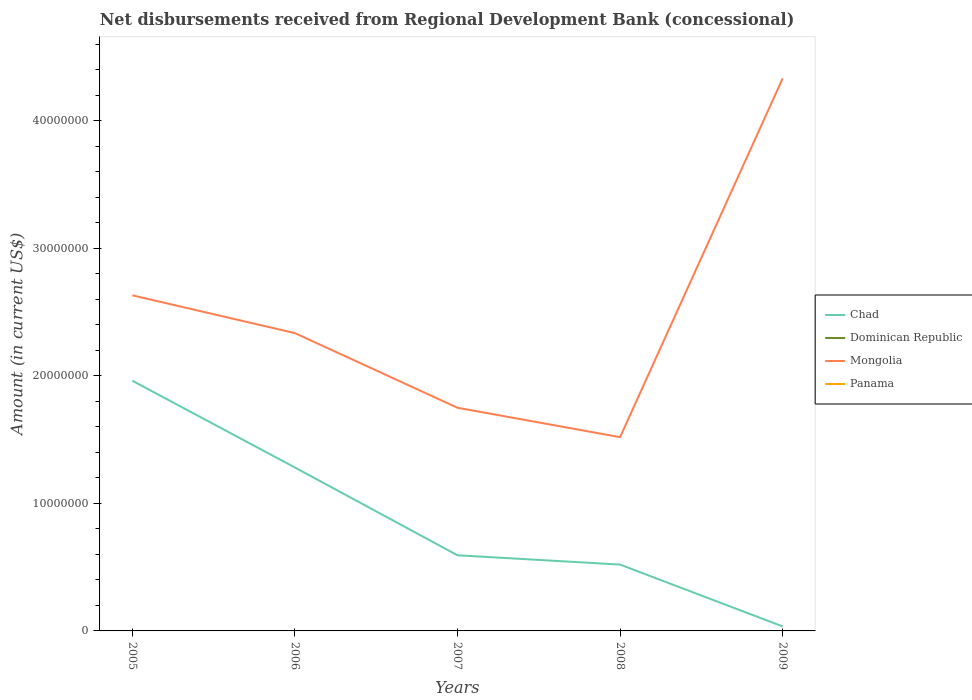How many different coloured lines are there?
Make the answer very short. 2. Across all years, what is the maximum amount of disbursements received from Regional Development Bank in Chad?
Provide a succinct answer. 3.53e+05. What is the total amount of disbursements received from Regional Development Bank in Chad in the graph?
Your response must be concise. 6.80e+06. What is the difference between the highest and the second highest amount of disbursements received from Regional Development Bank in Chad?
Offer a terse response. 1.93e+07. What is the difference between the highest and the lowest amount of disbursements received from Regional Development Bank in Dominican Republic?
Keep it short and to the point. 0. Is the amount of disbursements received from Regional Development Bank in Panama strictly greater than the amount of disbursements received from Regional Development Bank in Chad over the years?
Offer a terse response. Yes. How many lines are there?
Ensure brevity in your answer.  2. How many years are there in the graph?
Your answer should be compact. 5. Does the graph contain grids?
Your response must be concise. No. What is the title of the graph?
Keep it short and to the point. Net disbursements received from Regional Development Bank (concessional). What is the label or title of the X-axis?
Give a very brief answer. Years. What is the Amount (in current US$) in Chad in 2005?
Keep it short and to the point. 1.96e+07. What is the Amount (in current US$) of Dominican Republic in 2005?
Keep it short and to the point. 0. What is the Amount (in current US$) of Mongolia in 2005?
Make the answer very short. 2.63e+07. What is the Amount (in current US$) in Panama in 2005?
Keep it short and to the point. 0. What is the Amount (in current US$) in Chad in 2006?
Your response must be concise. 1.28e+07. What is the Amount (in current US$) in Mongolia in 2006?
Give a very brief answer. 2.33e+07. What is the Amount (in current US$) in Panama in 2006?
Keep it short and to the point. 0. What is the Amount (in current US$) in Chad in 2007?
Keep it short and to the point. 5.93e+06. What is the Amount (in current US$) of Dominican Republic in 2007?
Offer a very short reply. 0. What is the Amount (in current US$) in Mongolia in 2007?
Ensure brevity in your answer.  1.75e+07. What is the Amount (in current US$) of Panama in 2007?
Your answer should be very brief. 0. What is the Amount (in current US$) in Chad in 2008?
Your response must be concise. 5.20e+06. What is the Amount (in current US$) in Mongolia in 2008?
Offer a very short reply. 1.52e+07. What is the Amount (in current US$) of Chad in 2009?
Offer a terse response. 3.53e+05. What is the Amount (in current US$) in Mongolia in 2009?
Provide a short and direct response. 4.33e+07. Across all years, what is the maximum Amount (in current US$) in Chad?
Offer a terse response. 1.96e+07. Across all years, what is the maximum Amount (in current US$) in Mongolia?
Offer a very short reply. 4.33e+07. Across all years, what is the minimum Amount (in current US$) of Chad?
Make the answer very short. 3.53e+05. Across all years, what is the minimum Amount (in current US$) of Mongolia?
Provide a short and direct response. 1.52e+07. What is the total Amount (in current US$) of Chad in the graph?
Make the answer very short. 4.39e+07. What is the total Amount (in current US$) in Dominican Republic in the graph?
Your answer should be very brief. 0. What is the total Amount (in current US$) in Mongolia in the graph?
Give a very brief answer. 1.26e+08. What is the difference between the Amount (in current US$) in Chad in 2005 and that in 2006?
Provide a succinct answer. 6.80e+06. What is the difference between the Amount (in current US$) in Mongolia in 2005 and that in 2006?
Offer a very short reply. 2.96e+06. What is the difference between the Amount (in current US$) in Chad in 2005 and that in 2007?
Make the answer very short. 1.37e+07. What is the difference between the Amount (in current US$) in Mongolia in 2005 and that in 2007?
Ensure brevity in your answer.  8.81e+06. What is the difference between the Amount (in current US$) in Chad in 2005 and that in 2008?
Offer a terse response. 1.44e+07. What is the difference between the Amount (in current US$) of Mongolia in 2005 and that in 2008?
Keep it short and to the point. 1.11e+07. What is the difference between the Amount (in current US$) in Chad in 2005 and that in 2009?
Offer a very short reply. 1.93e+07. What is the difference between the Amount (in current US$) in Mongolia in 2005 and that in 2009?
Your answer should be compact. -1.70e+07. What is the difference between the Amount (in current US$) in Chad in 2006 and that in 2007?
Your answer should be very brief. 6.88e+06. What is the difference between the Amount (in current US$) of Mongolia in 2006 and that in 2007?
Your response must be concise. 5.85e+06. What is the difference between the Amount (in current US$) in Chad in 2006 and that in 2008?
Offer a very short reply. 7.61e+06. What is the difference between the Amount (in current US$) in Mongolia in 2006 and that in 2008?
Your response must be concise. 8.16e+06. What is the difference between the Amount (in current US$) of Chad in 2006 and that in 2009?
Keep it short and to the point. 1.25e+07. What is the difference between the Amount (in current US$) in Mongolia in 2006 and that in 2009?
Keep it short and to the point. -2.00e+07. What is the difference between the Amount (in current US$) in Chad in 2007 and that in 2008?
Your answer should be compact. 7.30e+05. What is the difference between the Amount (in current US$) in Mongolia in 2007 and that in 2008?
Make the answer very short. 2.30e+06. What is the difference between the Amount (in current US$) in Chad in 2007 and that in 2009?
Offer a very short reply. 5.58e+06. What is the difference between the Amount (in current US$) in Mongolia in 2007 and that in 2009?
Provide a succinct answer. -2.58e+07. What is the difference between the Amount (in current US$) in Chad in 2008 and that in 2009?
Your answer should be compact. 4.85e+06. What is the difference between the Amount (in current US$) in Mongolia in 2008 and that in 2009?
Ensure brevity in your answer.  -2.81e+07. What is the difference between the Amount (in current US$) in Chad in 2005 and the Amount (in current US$) in Mongolia in 2006?
Make the answer very short. -3.73e+06. What is the difference between the Amount (in current US$) in Chad in 2005 and the Amount (in current US$) in Mongolia in 2007?
Keep it short and to the point. 2.12e+06. What is the difference between the Amount (in current US$) of Chad in 2005 and the Amount (in current US$) of Mongolia in 2008?
Provide a short and direct response. 4.42e+06. What is the difference between the Amount (in current US$) in Chad in 2005 and the Amount (in current US$) in Mongolia in 2009?
Make the answer very short. -2.37e+07. What is the difference between the Amount (in current US$) in Chad in 2006 and the Amount (in current US$) in Mongolia in 2007?
Give a very brief answer. -4.68e+06. What is the difference between the Amount (in current US$) of Chad in 2006 and the Amount (in current US$) of Mongolia in 2008?
Your answer should be compact. -2.38e+06. What is the difference between the Amount (in current US$) of Chad in 2006 and the Amount (in current US$) of Mongolia in 2009?
Make the answer very short. -3.05e+07. What is the difference between the Amount (in current US$) in Chad in 2007 and the Amount (in current US$) in Mongolia in 2008?
Your answer should be very brief. -9.26e+06. What is the difference between the Amount (in current US$) in Chad in 2007 and the Amount (in current US$) in Mongolia in 2009?
Keep it short and to the point. -3.74e+07. What is the difference between the Amount (in current US$) in Chad in 2008 and the Amount (in current US$) in Mongolia in 2009?
Your answer should be compact. -3.81e+07. What is the average Amount (in current US$) of Chad per year?
Your answer should be very brief. 8.78e+06. What is the average Amount (in current US$) in Dominican Republic per year?
Ensure brevity in your answer.  0. What is the average Amount (in current US$) in Mongolia per year?
Your answer should be very brief. 2.51e+07. In the year 2005, what is the difference between the Amount (in current US$) of Chad and Amount (in current US$) of Mongolia?
Ensure brevity in your answer.  -6.70e+06. In the year 2006, what is the difference between the Amount (in current US$) in Chad and Amount (in current US$) in Mongolia?
Provide a succinct answer. -1.05e+07. In the year 2007, what is the difference between the Amount (in current US$) of Chad and Amount (in current US$) of Mongolia?
Keep it short and to the point. -1.16e+07. In the year 2008, what is the difference between the Amount (in current US$) of Chad and Amount (in current US$) of Mongolia?
Provide a succinct answer. -9.99e+06. In the year 2009, what is the difference between the Amount (in current US$) in Chad and Amount (in current US$) in Mongolia?
Provide a short and direct response. -4.30e+07. What is the ratio of the Amount (in current US$) in Chad in 2005 to that in 2006?
Make the answer very short. 1.53. What is the ratio of the Amount (in current US$) in Mongolia in 2005 to that in 2006?
Keep it short and to the point. 1.13. What is the ratio of the Amount (in current US$) of Chad in 2005 to that in 2007?
Ensure brevity in your answer.  3.31. What is the ratio of the Amount (in current US$) of Mongolia in 2005 to that in 2007?
Provide a short and direct response. 1.5. What is the ratio of the Amount (in current US$) of Chad in 2005 to that in 2008?
Offer a very short reply. 3.77. What is the ratio of the Amount (in current US$) in Mongolia in 2005 to that in 2008?
Provide a short and direct response. 1.73. What is the ratio of the Amount (in current US$) of Chad in 2005 to that in 2009?
Your answer should be compact. 55.56. What is the ratio of the Amount (in current US$) in Mongolia in 2005 to that in 2009?
Ensure brevity in your answer.  0.61. What is the ratio of the Amount (in current US$) of Chad in 2006 to that in 2007?
Ensure brevity in your answer.  2.16. What is the ratio of the Amount (in current US$) of Mongolia in 2006 to that in 2007?
Your answer should be compact. 1.33. What is the ratio of the Amount (in current US$) of Chad in 2006 to that in 2008?
Offer a very short reply. 2.46. What is the ratio of the Amount (in current US$) of Mongolia in 2006 to that in 2008?
Offer a very short reply. 1.54. What is the ratio of the Amount (in current US$) in Chad in 2006 to that in 2009?
Your response must be concise. 36.29. What is the ratio of the Amount (in current US$) of Mongolia in 2006 to that in 2009?
Give a very brief answer. 0.54. What is the ratio of the Amount (in current US$) of Chad in 2007 to that in 2008?
Your answer should be very brief. 1.14. What is the ratio of the Amount (in current US$) of Mongolia in 2007 to that in 2008?
Your response must be concise. 1.15. What is the ratio of the Amount (in current US$) in Chad in 2007 to that in 2009?
Offer a very short reply. 16.8. What is the ratio of the Amount (in current US$) of Mongolia in 2007 to that in 2009?
Offer a terse response. 0.4. What is the ratio of the Amount (in current US$) of Chad in 2008 to that in 2009?
Provide a succinct answer. 14.73. What is the ratio of the Amount (in current US$) of Mongolia in 2008 to that in 2009?
Give a very brief answer. 0.35. What is the difference between the highest and the second highest Amount (in current US$) in Chad?
Offer a terse response. 6.80e+06. What is the difference between the highest and the second highest Amount (in current US$) in Mongolia?
Your answer should be very brief. 1.70e+07. What is the difference between the highest and the lowest Amount (in current US$) of Chad?
Offer a terse response. 1.93e+07. What is the difference between the highest and the lowest Amount (in current US$) of Mongolia?
Keep it short and to the point. 2.81e+07. 